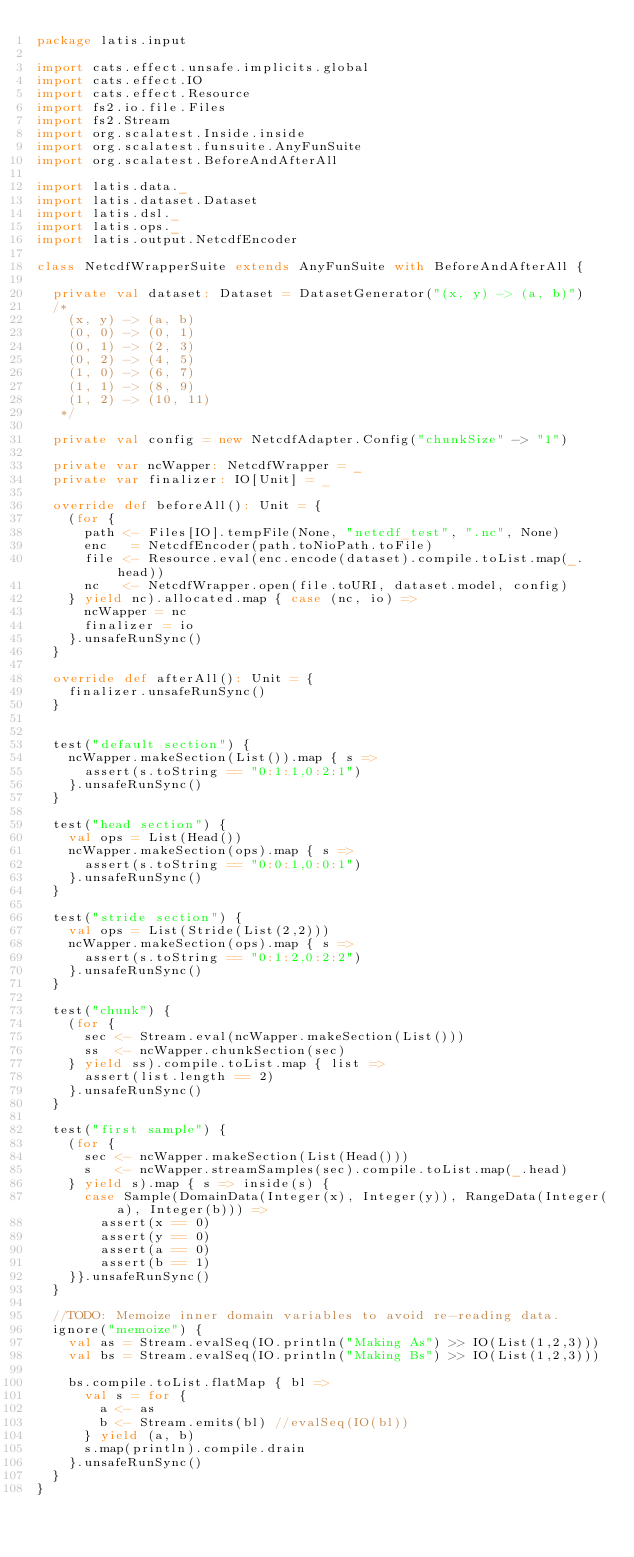Convert code to text. <code><loc_0><loc_0><loc_500><loc_500><_Scala_>package latis.input

import cats.effect.unsafe.implicits.global
import cats.effect.IO
import cats.effect.Resource
import fs2.io.file.Files
import fs2.Stream
import org.scalatest.Inside.inside
import org.scalatest.funsuite.AnyFunSuite
import org.scalatest.BeforeAndAfterAll

import latis.data._
import latis.dataset.Dataset
import latis.dsl._
import latis.ops._
import latis.output.NetcdfEncoder

class NetcdfWrapperSuite extends AnyFunSuite with BeforeAndAfterAll {

  private val dataset: Dataset = DatasetGenerator("(x, y) -> (a, b)")
  /*
    (x, y) -> (a, b)
    (0, 0) -> (0, 1)
    (0, 1) -> (2, 3)
    (0, 2) -> (4, 5)
    (1, 0) -> (6, 7)
    (1, 1) -> (8, 9)
    (1, 2) -> (10, 11)
   */

  private val config = new NetcdfAdapter.Config("chunkSize" -> "1")

  private var ncWapper: NetcdfWrapper = _
  private var finalizer: IO[Unit] = _

  override def beforeAll(): Unit = {
    (for {
      path <- Files[IO].tempFile(None, "netcdf_test", ".nc", None)
      enc   = NetcdfEncoder(path.toNioPath.toFile)
      file <- Resource.eval(enc.encode(dataset).compile.toList.map(_.head))
      nc   <- NetcdfWrapper.open(file.toURI, dataset.model, config)
    } yield nc).allocated.map { case (nc, io) =>
      ncWapper = nc
      finalizer = io
    }.unsafeRunSync()
  }

  override def afterAll(): Unit = {
    finalizer.unsafeRunSync()
  }


  test("default section") {
    ncWapper.makeSection(List()).map { s =>
      assert(s.toString == "0:1:1,0:2:1")
    }.unsafeRunSync()
  }

  test("head section") {
    val ops = List(Head())
    ncWapper.makeSection(ops).map { s =>
      assert(s.toString == "0:0:1,0:0:1")
    }.unsafeRunSync()
  }

  test("stride section") {
    val ops = List(Stride(List(2,2)))
    ncWapper.makeSection(ops).map { s =>
      assert(s.toString == "0:1:2,0:2:2")
    }.unsafeRunSync()
  }

  test("chunk") {
    (for {
      sec <- Stream.eval(ncWapper.makeSection(List()))
      ss  <- ncWapper.chunkSection(sec)
    } yield ss).compile.toList.map { list =>
      assert(list.length == 2)
    }.unsafeRunSync()
  }

  test("first sample") {
    (for {
      sec <- ncWapper.makeSection(List(Head()))
      s   <- ncWapper.streamSamples(sec).compile.toList.map(_.head)
    } yield s).map { s => inside(s) {
      case Sample(DomainData(Integer(x), Integer(y)), RangeData(Integer(a), Integer(b))) =>
        assert(x == 0)
        assert(y == 0)
        assert(a == 0)
        assert(b == 1)
    }}.unsafeRunSync()
  }

  //TODO: Memoize inner domain variables to avoid re-reading data.
  ignore("memoize") {
    val as = Stream.evalSeq(IO.println("Making As") >> IO(List(1,2,3)))
    val bs = Stream.evalSeq(IO.println("Making Bs") >> IO(List(1,2,3)))

    bs.compile.toList.flatMap { bl =>
      val s = for {
        a <- as
        b <- Stream.emits(bl) //evalSeq(IO(bl))
      } yield (a, b)
      s.map(println).compile.drain
    }.unsafeRunSync()
  }
}
</code> 